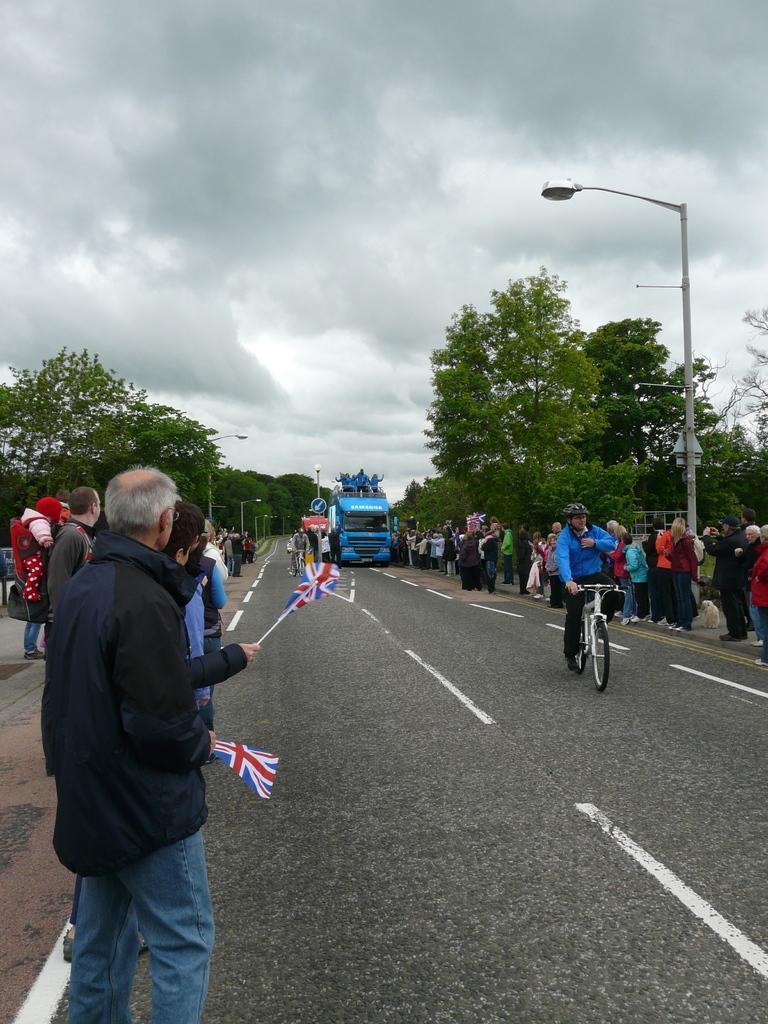How would you summarize this image in a sentence or two? There is a road. On the road a person wearing helmet is riding a cycle. On the sides there are people standing. Some people are holding flags on the left side. There are trees. And there is a street light pole on the right side. In the back there is a vehicle with some people are standing on that. Near to that there is a sign board. In the background there is sky with clouds. 